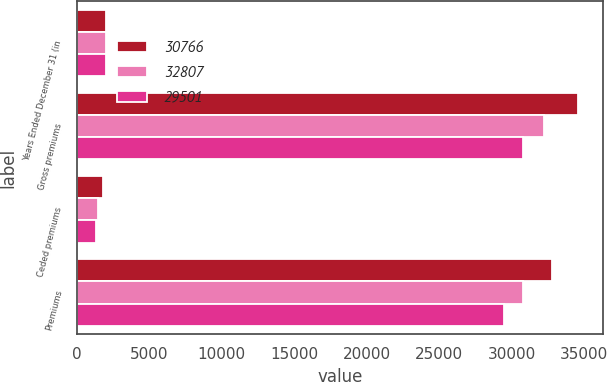Convert chart to OTSL. <chart><loc_0><loc_0><loc_500><loc_500><stacked_bar_chart><ecel><fcel>Years Ended December 31 (in<fcel>Gross premiums<fcel>Ceded premiums<fcel>Premiums<nl><fcel>30766<fcel>2007<fcel>34585<fcel>1778<fcel>32807<nl><fcel>32807<fcel>2006<fcel>32247<fcel>1481<fcel>30766<nl><fcel>29501<fcel>2005<fcel>30818<fcel>1317<fcel>29501<nl></chart> 